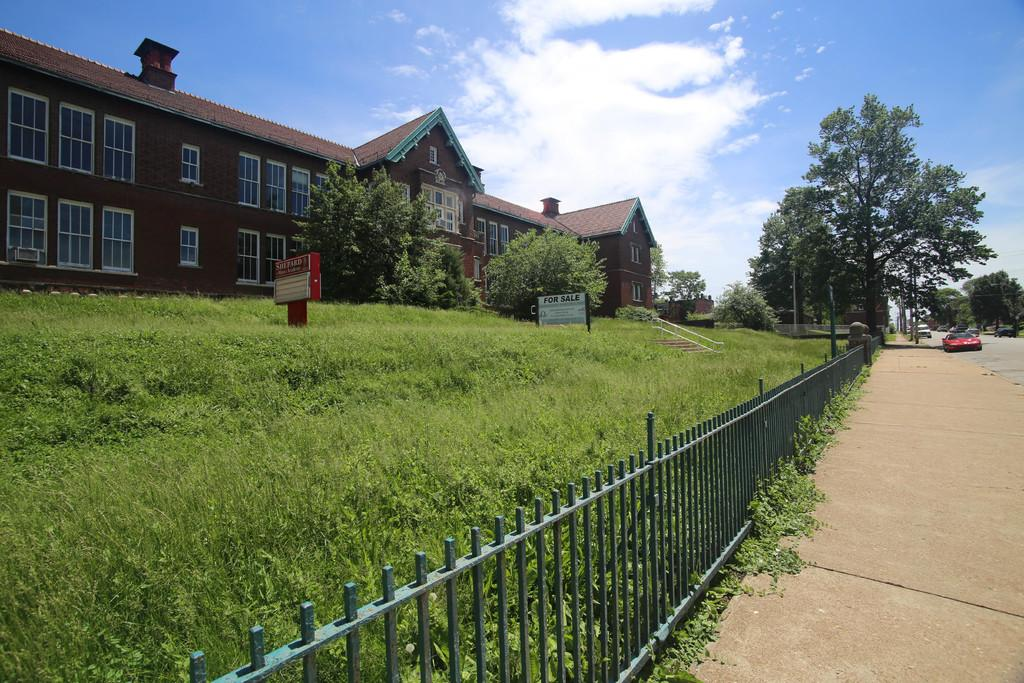What type of structure can be seen in the image? There is a building in the image. What architectural features are present on the building? There are walls, windows, boards, railings, and poles in the image. What natural elements are visible in the image? There are trees and plants in the image. What man-made elements are visible in the image? There are vehicles, a walkway, and a road in the image. What can be seen in the background of the image? The sky is visible in the background of the image. Where is the rodent hiding in the image? There is no rodent present in the image. What type of vegetable is being used as a decoration in the image? There are no vegetables present in the image. What type of fire-fighting equipment can be seen in the image? There is no fire-fighting equipment, such as a hydrant, present in the image. 